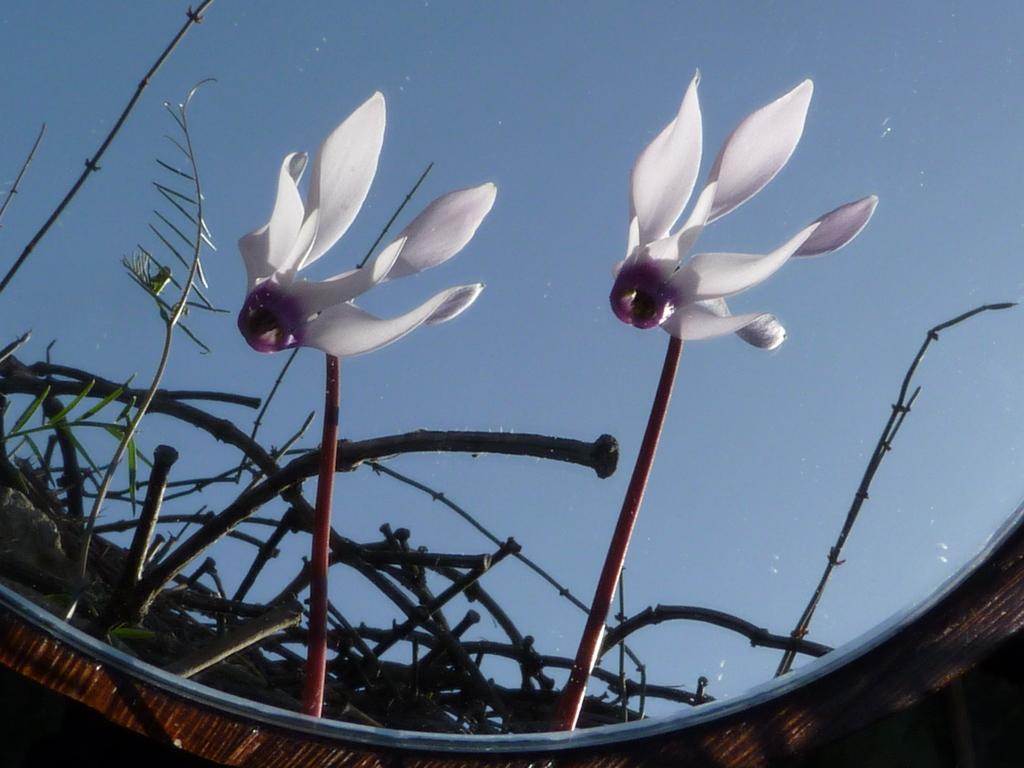Please provide a concise description of this image. In this picture we can see a mirror. Through mirror we can see the plants, flowers and sky. 